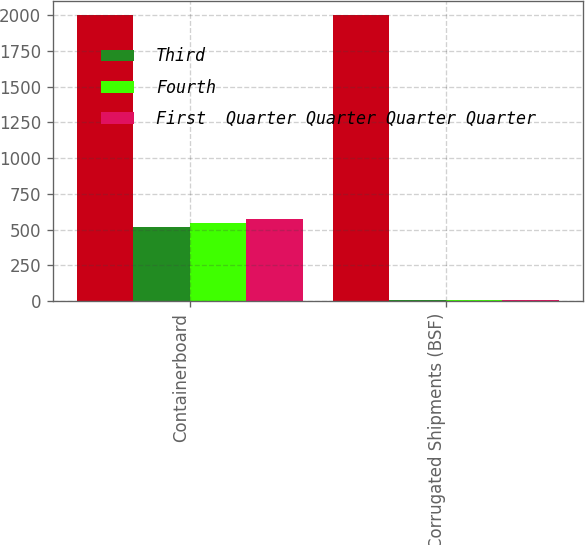Convert chart. <chart><loc_0><loc_0><loc_500><loc_500><stacked_bar_chart><ecel><fcel>Containerboard<fcel>Corrugated Shipments (BSF)<nl><fcel>nan<fcel>2002<fcel>2002<nl><fcel>Third<fcel>520<fcel>6.5<nl><fcel>Fourth<fcel>548<fcel>7.2<nl><fcel>First  Quarter Quarter Quarter Quarter<fcel>578<fcel>7.3<nl></chart> 